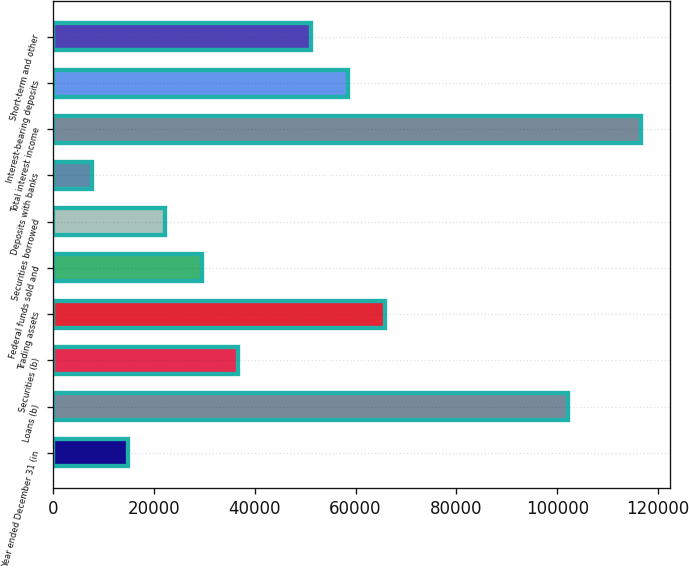Convert chart. <chart><loc_0><loc_0><loc_500><loc_500><bar_chart><fcel>Year ended December 31 (in<fcel>Loans (b)<fcel>Securities (b)<fcel>Trading assets<fcel>Federal funds sold and<fcel>Securities borrowed<fcel>Deposits with banks<fcel>Total interest income<fcel>Interest-bearing deposits<fcel>Short-term and other<nl><fcel>14927.6<fcel>102063<fcel>36711.5<fcel>65756.7<fcel>29450.2<fcel>22188.9<fcel>7666.3<fcel>116586<fcel>58495.4<fcel>51234.1<nl></chart> 